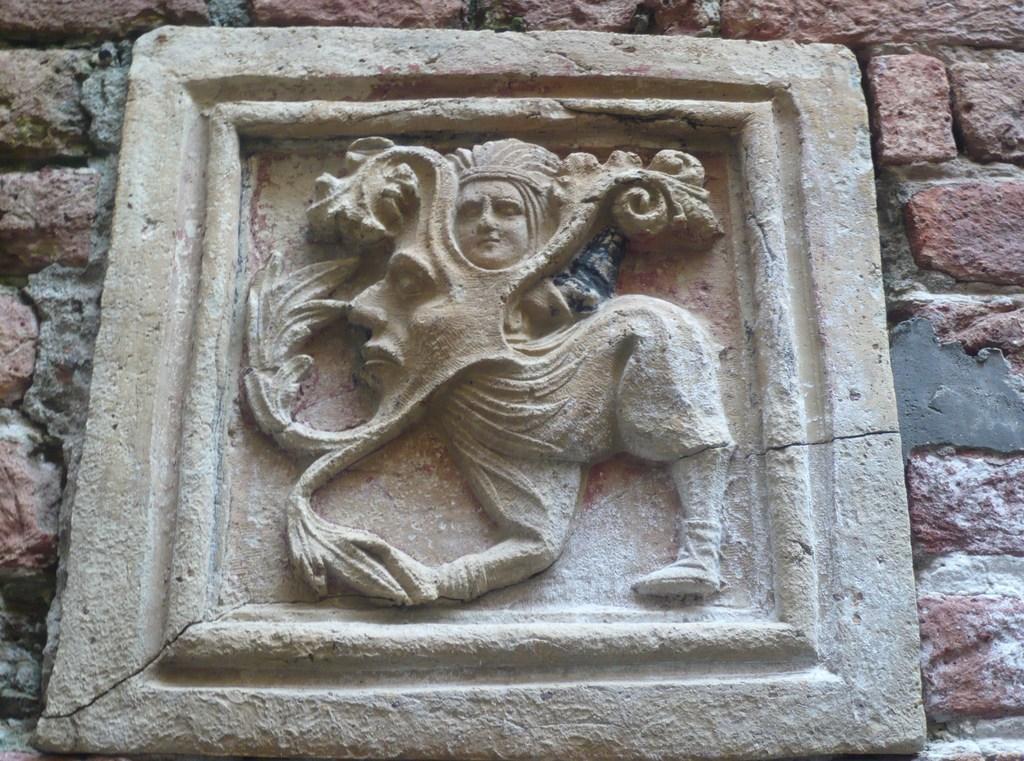Could you give a brief overview of what you see in this image? In the picture I can see sculpture to the brick wall. 